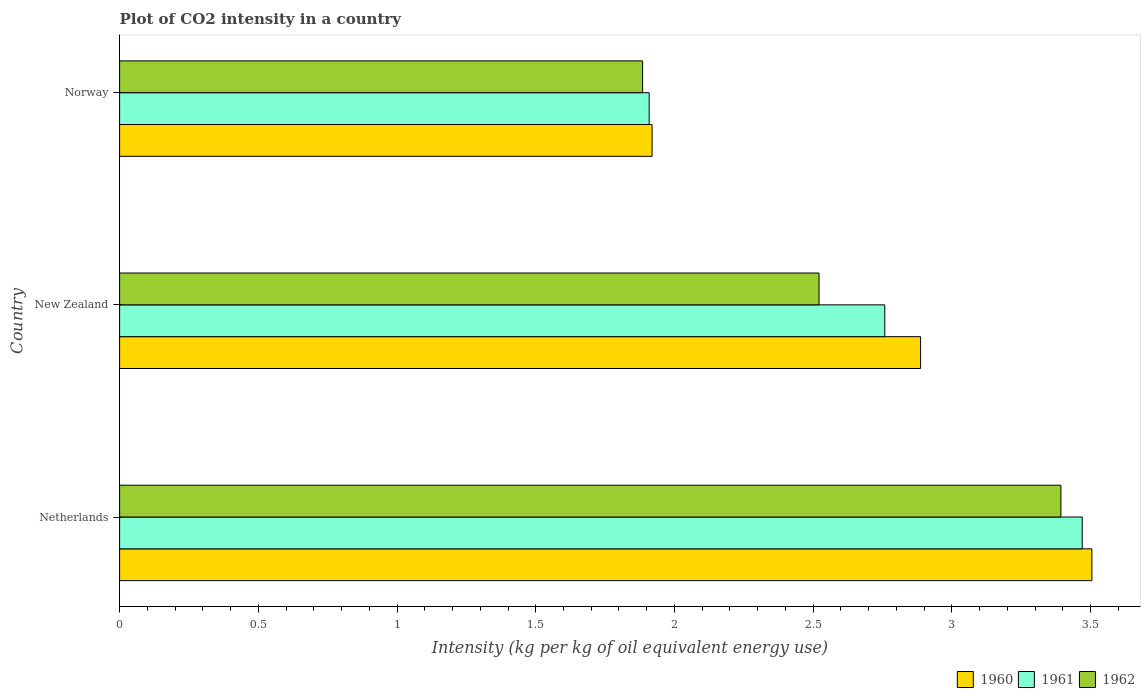How many different coloured bars are there?
Provide a succinct answer. 3. Are the number of bars on each tick of the Y-axis equal?
Offer a terse response. Yes. How many bars are there on the 3rd tick from the top?
Your answer should be compact. 3. What is the label of the 1st group of bars from the top?
Your answer should be very brief. Norway. What is the CO2 intensity in in 1961 in New Zealand?
Offer a very short reply. 2.76. Across all countries, what is the maximum CO2 intensity in in 1960?
Your response must be concise. 3.5. Across all countries, what is the minimum CO2 intensity in in 1962?
Provide a succinct answer. 1.89. In which country was the CO2 intensity in in 1960 minimum?
Give a very brief answer. Norway. What is the total CO2 intensity in in 1962 in the graph?
Your answer should be very brief. 7.8. What is the difference between the CO2 intensity in in 1961 in Netherlands and that in New Zealand?
Your response must be concise. 0.71. What is the difference between the CO2 intensity in in 1961 in Netherlands and the CO2 intensity in in 1960 in Norway?
Ensure brevity in your answer.  1.55. What is the average CO2 intensity in in 1960 per country?
Your answer should be compact. 2.77. What is the difference between the CO2 intensity in in 1960 and CO2 intensity in in 1962 in New Zealand?
Offer a terse response. 0.37. In how many countries, is the CO2 intensity in in 1960 greater than 0.6 kg?
Offer a very short reply. 3. What is the ratio of the CO2 intensity in in 1961 in Netherlands to that in New Zealand?
Your answer should be very brief. 1.26. What is the difference between the highest and the second highest CO2 intensity in in 1960?
Provide a succinct answer. 0.62. What is the difference between the highest and the lowest CO2 intensity in in 1961?
Make the answer very short. 1.56. In how many countries, is the CO2 intensity in in 1960 greater than the average CO2 intensity in in 1960 taken over all countries?
Give a very brief answer. 2. Is the sum of the CO2 intensity in in 1962 in Netherlands and Norway greater than the maximum CO2 intensity in in 1960 across all countries?
Keep it short and to the point. Yes. What does the 3rd bar from the bottom in Norway represents?
Your answer should be compact. 1962. Is it the case that in every country, the sum of the CO2 intensity in in 1960 and CO2 intensity in in 1961 is greater than the CO2 intensity in in 1962?
Your response must be concise. Yes. How many countries are there in the graph?
Provide a short and direct response. 3. Are the values on the major ticks of X-axis written in scientific E-notation?
Ensure brevity in your answer.  No. Where does the legend appear in the graph?
Keep it short and to the point. Bottom right. How many legend labels are there?
Offer a very short reply. 3. How are the legend labels stacked?
Your response must be concise. Horizontal. What is the title of the graph?
Your answer should be very brief. Plot of CO2 intensity in a country. What is the label or title of the X-axis?
Offer a terse response. Intensity (kg per kg of oil equivalent energy use). What is the Intensity (kg per kg of oil equivalent energy use) in 1960 in Netherlands?
Your response must be concise. 3.5. What is the Intensity (kg per kg of oil equivalent energy use) of 1961 in Netherlands?
Make the answer very short. 3.47. What is the Intensity (kg per kg of oil equivalent energy use) of 1962 in Netherlands?
Offer a terse response. 3.39. What is the Intensity (kg per kg of oil equivalent energy use) of 1960 in New Zealand?
Ensure brevity in your answer.  2.89. What is the Intensity (kg per kg of oil equivalent energy use) of 1961 in New Zealand?
Your response must be concise. 2.76. What is the Intensity (kg per kg of oil equivalent energy use) in 1962 in New Zealand?
Ensure brevity in your answer.  2.52. What is the Intensity (kg per kg of oil equivalent energy use) in 1960 in Norway?
Your answer should be very brief. 1.92. What is the Intensity (kg per kg of oil equivalent energy use) of 1961 in Norway?
Ensure brevity in your answer.  1.91. What is the Intensity (kg per kg of oil equivalent energy use) of 1962 in Norway?
Ensure brevity in your answer.  1.89. Across all countries, what is the maximum Intensity (kg per kg of oil equivalent energy use) of 1960?
Ensure brevity in your answer.  3.5. Across all countries, what is the maximum Intensity (kg per kg of oil equivalent energy use) in 1961?
Your response must be concise. 3.47. Across all countries, what is the maximum Intensity (kg per kg of oil equivalent energy use) in 1962?
Offer a terse response. 3.39. Across all countries, what is the minimum Intensity (kg per kg of oil equivalent energy use) of 1960?
Keep it short and to the point. 1.92. Across all countries, what is the minimum Intensity (kg per kg of oil equivalent energy use) in 1961?
Provide a short and direct response. 1.91. Across all countries, what is the minimum Intensity (kg per kg of oil equivalent energy use) of 1962?
Your answer should be compact. 1.89. What is the total Intensity (kg per kg of oil equivalent energy use) of 1960 in the graph?
Provide a short and direct response. 8.31. What is the total Intensity (kg per kg of oil equivalent energy use) in 1961 in the graph?
Provide a short and direct response. 8.14. What is the total Intensity (kg per kg of oil equivalent energy use) in 1962 in the graph?
Provide a succinct answer. 7.8. What is the difference between the Intensity (kg per kg of oil equivalent energy use) of 1960 in Netherlands and that in New Zealand?
Provide a short and direct response. 0.62. What is the difference between the Intensity (kg per kg of oil equivalent energy use) of 1961 in Netherlands and that in New Zealand?
Provide a short and direct response. 0.71. What is the difference between the Intensity (kg per kg of oil equivalent energy use) in 1962 in Netherlands and that in New Zealand?
Your answer should be very brief. 0.87. What is the difference between the Intensity (kg per kg of oil equivalent energy use) of 1960 in Netherlands and that in Norway?
Your answer should be very brief. 1.59. What is the difference between the Intensity (kg per kg of oil equivalent energy use) of 1961 in Netherlands and that in Norway?
Offer a terse response. 1.56. What is the difference between the Intensity (kg per kg of oil equivalent energy use) in 1962 in Netherlands and that in Norway?
Your response must be concise. 1.51. What is the difference between the Intensity (kg per kg of oil equivalent energy use) in 1960 in New Zealand and that in Norway?
Offer a terse response. 0.97. What is the difference between the Intensity (kg per kg of oil equivalent energy use) in 1961 in New Zealand and that in Norway?
Your answer should be very brief. 0.85. What is the difference between the Intensity (kg per kg of oil equivalent energy use) in 1962 in New Zealand and that in Norway?
Give a very brief answer. 0.64. What is the difference between the Intensity (kg per kg of oil equivalent energy use) of 1960 in Netherlands and the Intensity (kg per kg of oil equivalent energy use) of 1961 in New Zealand?
Your answer should be compact. 0.75. What is the difference between the Intensity (kg per kg of oil equivalent energy use) of 1960 in Netherlands and the Intensity (kg per kg of oil equivalent energy use) of 1962 in New Zealand?
Offer a terse response. 0.98. What is the difference between the Intensity (kg per kg of oil equivalent energy use) in 1961 in Netherlands and the Intensity (kg per kg of oil equivalent energy use) in 1962 in New Zealand?
Make the answer very short. 0.95. What is the difference between the Intensity (kg per kg of oil equivalent energy use) in 1960 in Netherlands and the Intensity (kg per kg of oil equivalent energy use) in 1961 in Norway?
Offer a very short reply. 1.6. What is the difference between the Intensity (kg per kg of oil equivalent energy use) of 1960 in Netherlands and the Intensity (kg per kg of oil equivalent energy use) of 1962 in Norway?
Provide a succinct answer. 1.62. What is the difference between the Intensity (kg per kg of oil equivalent energy use) of 1961 in Netherlands and the Intensity (kg per kg of oil equivalent energy use) of 1962 in Norway?
Keep it short and to the point. 1.58. What is the difference between the Intensity (kg per kg of oil equivalent energy use) of 1960 in New Zealand and the Intensity (kg per kg of oil equivalent energy use) of 1961 in Norway?
Offer a terse response. 0.98. What is the difference between the Intensity (kg per kg of oil equivalent energy use) of 1960 in New Zealand and the Intensity (kg per kg of oil equivalent energy use) of 1962 in Norway?
Give a very brief answer. 1. What is the difference between the Intensity (kg per kg of oil equivalent energy use) of 1961 in New Zealand and the Intensity (kg per kg of oil equivalent energy use) of 1962 in Norway?
Your answer should be compact. 0.87. What is the average Intensity (kg per kg of oil equivalent energy use) of 1960 per country?
Your response must be concise. 2.77. What is the average Intensity (kg per kg of oil equivalent energy use) in 1961 per country?
Your answer should be compact. 2.71. What is the average Intensity (kg per kg of oil equivalent energy use) of 1962 per country?
Keep it short and to the point. 2.6. What is the difference between the Intensity (kg per kg of oil equivalent energy use) in 1960 and Intensity (kg per kg of oil equivalent energy use) in 1961 in Netherlands?
Keep it short and to the point. 0.03. What is the difference between the Intensity (kg per kg of oil equivalent energy use) in 1960 and Intensity (kg per kg of oil equivalent energy use) in 1962 in Netherlands?
Make the answer very short. 0.11. What is the difference between the Intensity (kg per kg of oil equivalent energy use) in 1961 and Intensity (kg per kg of oil equivalent energy use) in 1962 in Netherlands?
Give a very brief answer. 0.08. What is the difference between the Intensity (kg per kg of oil equivalent energy use) of 1960 and Intensity (kg per kg of oil equivalent energy use) of 1961 in New Zealand?
Offer a very short reply. 0.13. What is the difference between the Intensity (kg per kg of oil equivalent energy use) of 1960 and Intensity (kg per kg of oil equivalent energy use) of 1962 in New Zealand?
Your response must be concise. 0.37. What is the difference between the Intensity (kg per kg of oil equivalent energy use) in 1961 and Intensity (kg per kg of oil equivalent energy use) in 1962 in New Zealand?
Make the answer very short. 0.24. What is the difference between the Intensity (kg per kg of oil equivalent energy use) of 1960 and Intensity (kg per kg of oil equivalent energy use) of 1961 in Norway?
Give a very brief answer. 0.01. What is the difference between the Intensity (kg per kg of oil equivalent energy use) of 1960 and Intensity (kg per kg of oil equivalent energy use) of 1962 in Norway?
Your answer should be very brief. 0.03. What is the difference between the Intensity (kg per kg of oil equivalent energy use) in 1961 and Intensity (kg per kg of oil equivalent energy use) in 1962 in Norway?
Offer a terse response. 0.02. What is the ratio of the Intensity (kg per kg of oil equivalent energy use) of 1960 in Netherlands to that in New Zealand?
Your answer should be compact. 1.21. What is the ratio of the Intensity (kg per kg of oil equivalent energy use) in 1961 in Netherlands to that in New Zealand?
Offer a very short reply. 1.26. What is the ratio of the Intensity (kg per kg of oil equivalent energy use) in 1962 in Netherlands to that in New Zealand?
Keep it short and to the point. 1.35. What is the ratio of the Intensity (kg per kg of oil equivalent energy use) in 1960 in Netherlands to that in Norway?
Give a very brief answer. 1.83. What is the ratio of the Intensity (kg per kg of oil equivalent energy use) of 1961 in Netherlands to that in Norway?
Offer a very short reply. 1.82. What is the ratio of the Intensity (kg per kg of oil equivalent energy use) in 1962 in Netherlands to that in Norway?
Offer a terse response. 1.8. What is the ratio of the Intensity (kg per kg of oil equivalent energy use) in 1960 in New Zealand to that in Norway?
Give a very brief answer. 1.5. What is the ratio of the Intensity (kg per kg of oil equivalent energy use) in 1961 in New Zealand to that in Norway?
Ensure brevity in your answer.  1.44. What is the ratio of the Intensity (kg per kg of oil equivalent energy use) of 1962 in New Zealand to that in Norway?
Ensure brevity in your answer.  1.34. What is the difference between the highest and the second highest Intensity (kg per kg of oil equivalent energy use) of 1960?
Offer a terse response. 0.62. What is the difference between the highest and the second highest Intensity (kg per kg of oil equivalent energy use) in 1961?
Give a very brief answer. 0.71. What is the difference between the highest and the second highest Intensity (kg per kg of oil equivalent energy use) in 1962?
Offer a very short reply. 0.87. What is the difference between the highest and the lowest Intensity (kg per kg of oil equivalent energy use) of 1960?
Your answer should be very brief. 1.59. What is the difference between the highest and the lowest Intensity (kg per kg of oil equivalent energy use) in 1961?
Give a very brief answer. 1.56. What is the difference between the highest and the lowest Intensity (kg per kg of oil equivalent energy use) in 1962?
Make the answer very short. 1.51. 